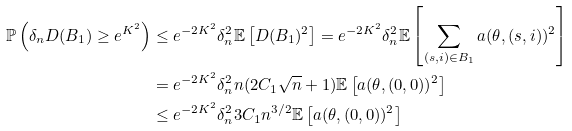<formula> <loc_0><loc_0><loc_500><loc_500>\mathbb { P } \left ( \delta _ { n } D ( B _ { 1 } ) \geq e ^ { K ^ { 2 } } \right ) & \leq e ^ { - 2 K ^ { 2 } } \delta _ { n } ^ { 2 } \mathbb { E } \left [ D ( B _ { 1 } ) ^ { 2 } \right ] = e ^ { - 2 K ^ { 2 } } \delta _ { n } ^ { 2 } \mathbb { E } \left [ \sum _ { ( s , i ) \in B _ { 1 } } a ( \theta , ( s , i ) ) ^ { 2 } \right ] \\ & = e ^ { - 2 K ^ { 2 } } \delta _ { n } ^ { 2 } n ( 2 C _ { 1 } \sqrt { n } + 1 ) \mathbb { E } \left [ a ( \theta , ( 0 , 0 ) ) ^ { 2 } \right ] \\ & \leq e ^ { - 2 K ^ { 2 } } \delta _ { n } ^ { 2 } 3 C _ { 1 } n ^ { 3 / 2 } \mathbb { E } \left [ a ( \theta , ( 0 , 0 ) ) ^ { 2 } \right ]</formula> 